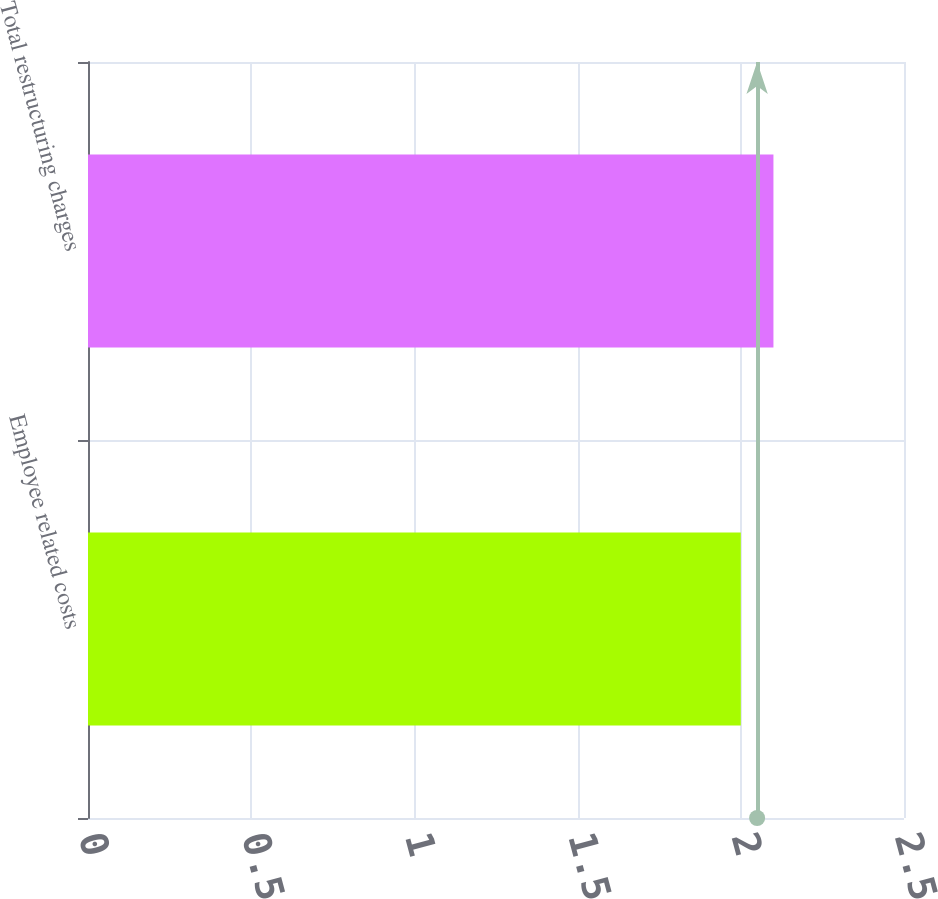Convert chart. <chart><loc_0><loc_0><loc_500><loc_500><bar_chart><fcel>Employee related costs<fcel>Total restructuring charges<nl><fcel>2<fcel>2.1<nl></chart> 